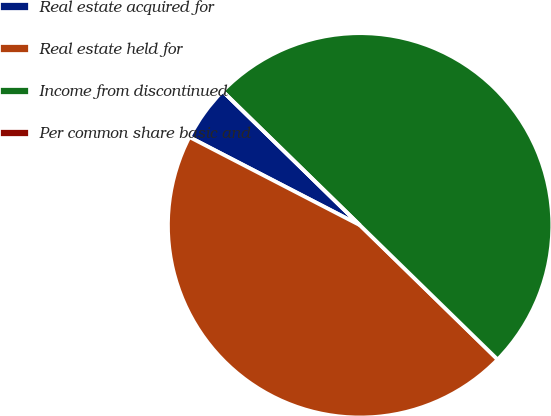<chart> <loc_0><loc_0><loc_500><loc_500><pie_chart><fcel>Real estate acquired for<fcel>Real estate held for<fcel>Income from discontinued<fcel>Per common share basic and<nl><fcel>4.71%<fcel>45.29%<fcel>50.0%<fcel>0.0%<nl></chart> 